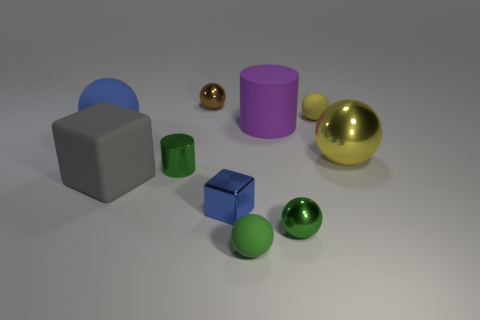Subtract all yellow spheres. How many spheres are left? 4 Subtract all tiny metallic spheres. How many spheres are left? 4 Subtract all purple spheres. Subtract all green cubes. How many spheres are left? 6 Subtract all blocks. How many objects are left? 8 Subtract 0 blue cylinders. How many objects are left? 10 Subtract all red matte cubes. Subtract all rubber cylinders. How many objects are left? 9 Add 9 big blue matte spheres. How many big blue matte spheres are left? 10 Add 1 small blocks. How many small blocks exist? 2 